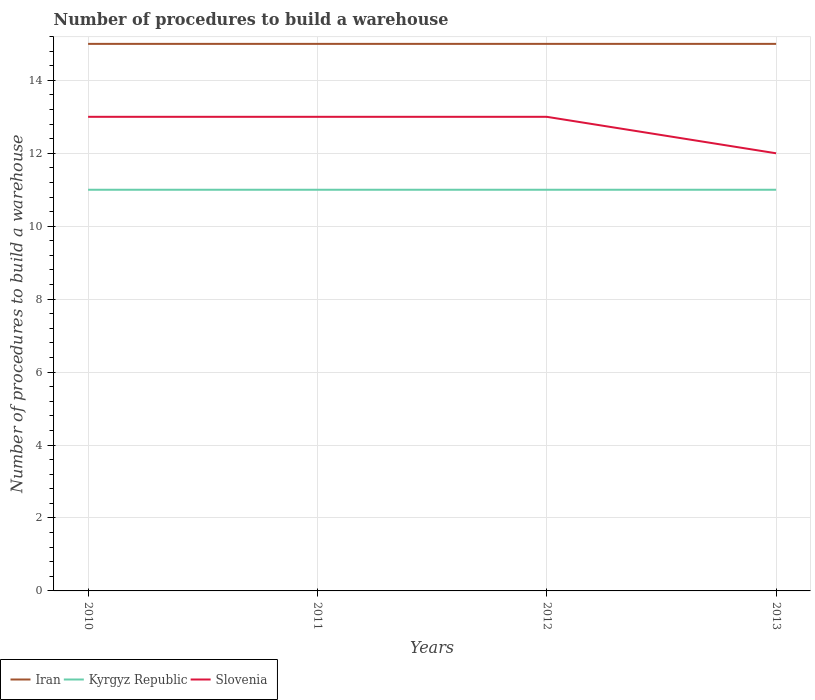Does the line corresponding to Iran intersect with the line corresponding to Kyrgyz Republic?
Give a very brief answer. No. Is the number of lines equal to the number of legend labels?
Provide a short and direct response. Yes. Across all years, what is the maximum number of procedures to build a warehouse in in Kyrgyz Republic?
Keep it short and to the point. 11. In which year was the number of procedures to build a warehouse in in Slovenia maximum?
Provide a succinct answer. 2013. What is the total number of procedures to build a warehouse in in Slovenia in the graph?
Make the answer very short. 1. What is the difference between the highest and the second highest number of procedures to build a warehouse in in Iran?
Provide a succinct answer. 0. Is the number of procedures to build a warehouse in in Slovenia strictly greater than the number of procedures to build a warehouse in in Iran over the years?
Provide a short and direct response. Yes. How many lines are there?
Your response must be concise. 3. How many years are there in the graph?
Make the answer very short. 4. What is the difference between two consecutive major ticks on the Y-axis?
Provide a short and direct response. 2. What is the title of the graph?
Your answer should be compact. Number of procedures to build a warehouse. What is the label or title of the X-axis?
Your response must be concise. Years. What is the label or title of the Y-axis?
Offer a terse response. Number of procedures to build a warehouse. What is the Number of procedures to build a warehouse of Slovenia in 2010?
Provide a succinct answer. 13. What is the Number of procedures to build a warehouse of Iran in 2011?
Give a very brief answer. 15. What is the Number of procedures to build a warehouse in Slovenia in 2011?
Make the answer very short. 13. What is the Number of procedures to build a warehouse of Iran in 2013?
Your response must be concise. 15. What is the Number of procedures to build a warehouse in Kyrgyz Republic in 2013?
Make the answer very short. 11. What is the Number of procedures to build a warehouse of Slovenia in 2013?
Your answer should be very brief. 12. Across all years, what is the maximum Number of procedures to build a warehouse in Kyrgyz Republic?
Ensure brevity in your answer.  11. Across all years, what is the minimum Number of procedures to build a warehouse of Iran?
Your answer should be very brief. 15. Across all years, what is the minimum Number of procedures to build a warehouse of Slovenia?
Provide a short and direct response. 12. What is the total Number of procedures to build a warehouse in Slovenia in the graph?
Your answer should be compact. 51. What is the difference between the Number of procedures to build a warehouse in Iran in 2010 and that in 2012?
Keep it short and to the point. 0. What is the difference between the Number of procedures to build a warehouse of Slovenia in 2010 and that in 2012?
Offer a terse response. 0. What is the difference between the Number of procedures to build a warehouse in Iran in 2010 and that in 2013?
Your answer should be very brief. 0. What is the difference between the Number of procedures to build a warehouse in Kyrgyz Republic in 2010 and that in 2013?
Make the answer very short. 0. What is the difference between the Number of procedures to build a warehouse in Slovenia in 2010 and that in 2013?
Your response must be concise. 1. What is the difference between the Number of procedures to build a warehouse in Kyrgyz Republic in 2011 and that in 2013?
Your answer should be compact. 0. What is the difference between the Number of procedures to build a warehouse of Slovenia in 2011 and that in 2013?
Your answer should be compact. 1. What is the difference between the Number of procedures to build a warehouse of Kyrgyz Republic in 2012 and that in 2013?
Offer a terse response. 0. What is the difference between the Number of procedures to build a warehouse of Iran in 2010 and the Number of procedures to build a warehouse of Kyrgyz Republic in 2011?
Your response must be concise. 4. What is the difference between the Number of procedures to build a warehouse of Iran in 2010 and the Number of procedures to build a warehouse of Slovenia in 2012?
Give a very brief answer. 2. What is the difference between the Number of procedures to build a warehouse in Kyrgyz Republic in 2010 and the Number of procedures to build a warehouse in Slovenia in 2012?
Make the answer very short. -2. What is the difference between the Number of procedures to build a warehouse of Iran in 2010 and the Number of procedures to build a warehouse of Kyrgyz Republic in 2013?
Offer a terse response. 4. What is the difference between the Number of procedures to build a warehouse in Iran in 2010 and the Number of procedures to build a warehouse in Slovenia in 2013?
Your answer should be very brief. 3. What is the difference between the Number of procedures to build a warehouse of Kyrgyz Republic in 2010 and the Number of procedures to build a warehouse of Slovenia in 2013?
Provide a succinct answer. -1. What is the difference between the Number of procedures to build a warehouse of Iran in 2011 and the Number of procedures to build a warehouse of Kyrgyz Republic in 2012?
Offer a terse response. 4. What is the difference between the Number of procedures to build a warehouse in Iran in 2011 and the Number of procedures to build a warehouse in Slovenia in 2012?
Ensure brevity in your answer.  2. What is the difference between the Number of procedures to build a warehouse in Iran in 2011 and the Number of procedures to build a warehouse in Kyrgyz Republic in 2013?
Your answer should be compact. 4. What is the difference between the Number of procedures to build a warehouse of Iran in 2011 and the Number of procedures to build a warehouse of Slovenia in 2013?
Offer a terse response. 3. What is the difference between the Number of procedures to build a warehouse in Kyrgyz Republic in 2011 and the Number of procedures to build a warehouse in Slovenia in 2013?
Provide a succinct answer. -1. What is the average Number of procedures to build a warehouse of Iran per year?
Offer a very short reply. 15. What is the average Number of procedures to build a warehouse of Kyrgyz Republic per year?
Keep it short and to the point. 11. What is the average Number of procedures to build a warehouse of Slovenia per year?
Give a very brief answer. 12.75. In the year 2010, what is the difference between the Number of procedures to build a warehouse in Iran and Number of procedures to build a warehouse in Kyrgyz Republic?
Offer a terse response. 4. In the year 2010, what is the difference between the Number of procedures to build a warehouse in Iran and Number of procedures to build a warehouse in Slovenia?
Your answer should be compact. 2. In the year 2010, what is the difference between the Number of procedures to build a warehouse in Kyrgyz Republic and Number of procedures to build a warehouse in Slovenia?
Provide a succinct answer. -2. In the year 2011, what is the difference between the Number of procedures to build a warehouse of Iran and Number of procedures to build a warehouse of Slovenia?
Offer a very short reply. 2. In the year 2012, what is the difference between the Number of procedures to build a warehouse in Iran and Number of procedures to build a warehouse in Slovenia?
Provide a short and direct response. 2. In the year 2012, what is the difference between the Number of procedures to build a warehouse of Kyrgyz Republic and Number of procedures to build a warehouse of Slovenia?
Offer a terse response. -2. In the year 2013, what is the difference between the Number of procedures to build a warehouse of Iran and Number of procedures to build a warehouse of Kyrgyz Republic?
Ensure brevity in your answer.  4. In the year 2013, what is the difference between the Number of procedures to build a warehouse of Kyrgyz Republic and Number of procedures to build a warehouse of Slovenia?
Offer a very short reply. -1. What is the ratio of the Number of procedures to build a warehouse of Iran in 2010 to that in 2011?
Make the answer very short. 1. What is the ratio of the Number of procedures to build a warehouse of Kyrgyz Republic in 2010 to that in 2012?
Offer a terse response. 1. What is the ratio of the Number of procedures to build a warehouse in Slovenia in 2010 to that in 2012?
Your answer should be very brief. 1. What is the ratio of the Number of procedures to build a warehouse of Kyrgyz Republic in 2010 to that in 2013?
Ensure brevity in your answer.  1. What is the ratio of the Number of procedures to build a warehouse of Slovenia in 2010 to that in 2013?
Your answer should be compact. 1.08. What is the ratio of the Number of procedures to build a warehouse of Iran in 2011 to that in 2012?
Offer a very short reply. 1. What is the ratio of the Number of procedures to build a warehouse in Kyrgyz Republic in 2011 to that in 2012?
Provide a short and direct response. 1. What is the ratio of the Number of procedures to build a warehouse in Slovenia in 2011 to that in 2013?
Give a very brief answer. 1.08. What is the ratio of the Number of procedures to build a warehouse of Iran in 2012 to that in 2013?
Offer a very short reply. 1. What is the ratio of the Number of procedures to build a warehouse of Kyrgyz Republic in 2012 to that in 2013?
Your answer should be compact. 1. What is the difference between the highest and the second highest Number of procedures to build a warehouse in Iran?
Keep it short and to the point. 0. 